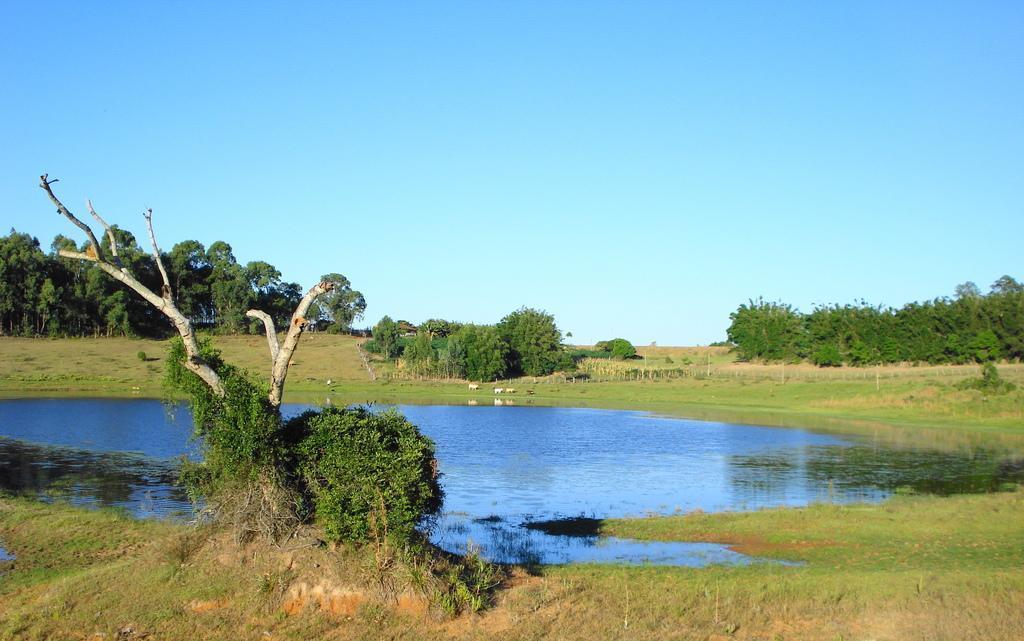Please provide a concise description of this image. In this picture we can see grass at the bottom, there is water in the middle, in the background there are some trees, we can see the sky at the top of the picture, they are looking like animals in the background. 